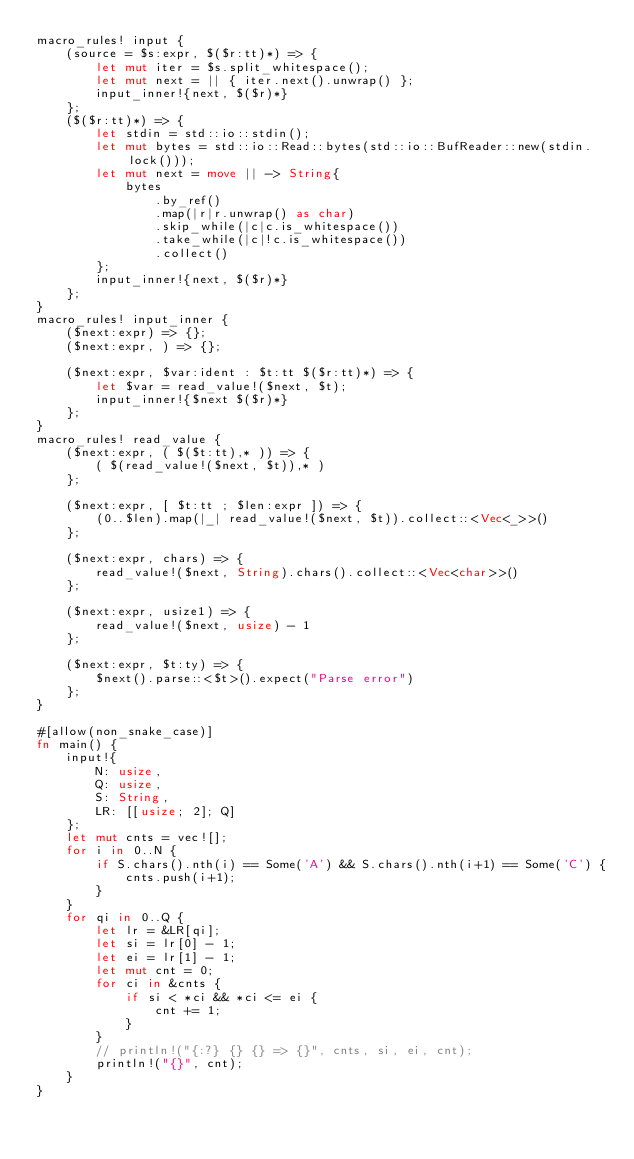<code> <loc_0><loc_0><loc_500><loc_500><_Rust_>macro_rules! input {
    (source = $s:expr, $($r:tt)*) => {
        let mut iter = $s.split_whitespace();
        let mut next = || { iter.next().unwrap() };
        input_inner!{next, $($r)*}
    };
    ($($r:tt)*) => {
        let stdin = std::io::stdin();
        let mut bytes = std::io::Read::bytes(std::io::BufReader::new(stdin.lock()));
        let mut next = move || -> String{
            bytes
                .by_ref()
                .map(|r|r.unwrap() as char)
                .skip_while(|c|c.is_whitespace())
                .take_while(|c|!c.is_whitespace())
                .collect()
        };
        input_inner!{next, $($r)*}
    };
}
macro_rules! input_inner {
    ($next:expr) => {};
    ($next:expr, ) => {};

    ($next:expr, $var:ident : $t:tt $($r:tt)*) => {
        let $var = read_value!($next, $t);
        input_inner!{$next $($r)*}
    };
}
macro_rules! read_value {
    ($next:expr, ( $($t:tt),* )) => {
        ( $(read_value!($next, $t)),* )
    };

    ($next:expr, [ $t:tt ; $len:expr ]) => {
        (0..$len).map(|_| read_value!($next, $t)).collect::<Vec<_>>()
    };

    ($next:expr, chars) => {
        read_value!($next, String).chars().collect::<Vec<char>>()
    };

    ($next:expr, usize1) => {
        read_value!($next, usize) - 1
    };

    ($next:expr, $t:ty) => {
        $next().parse::<$t>().expect("Parse error")
    };
}

#[allow(non_snake_case)]
fn main() {
    input!{
        N: usize,
        Q: usize,
        S: String,
        LR: [[usize; 2]; Q]
    };
    let mut cnts = vec![];
    for i in 0..N {
        if S.chars().nth(i) == Some('A') && S.chars().nth(i+1) == Some('C') {
            cnts.push(i+1);
        }
    }
    for qi in 0..Q {
        let lr = &LR[qi];
        let si = lr[0] - 1;
        let ei = lr[1] - 1;
        let mut cnt = 0;
        for ci in &cnts {
            if si < *ci && *ci <= ei {
                cnt += 1;
            }
        }
        // println!("{:?} {} {} => {}", cnts, si, ei, cnt);
        println!("{}", cnt);
    }
}</code> 